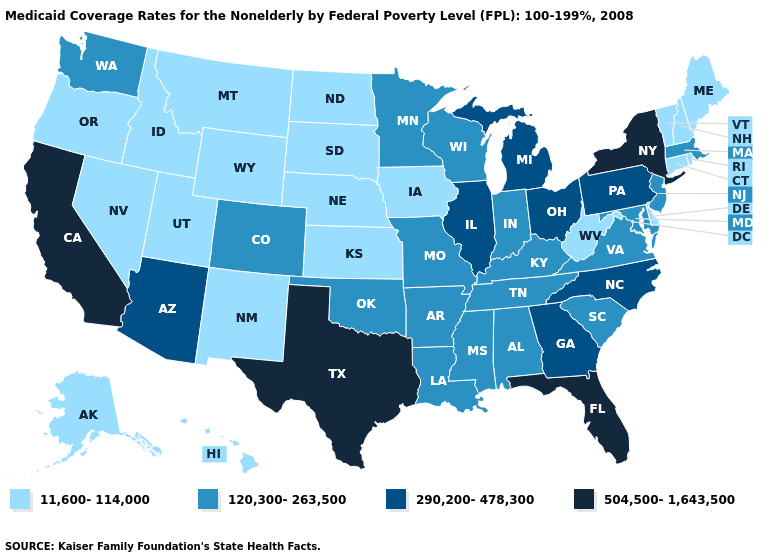Is the legend a continuous bar?
Short answer required. No. Name the states that have a value in the range 120,300-263,500?
Short answer required. Alabama, Arkansas, Colorado, Indiana, Kentucky, Louisiana, Maryland, Massachusetts, Minnesota, Mississippi, Missouri, New Jersey, Oklahoma, South Carolina, Tennessee, Virginia, Washington, Wisconsin. What is the value of Kansas?
Answer briefly. 11,600-114,000. Which states have the lowest value in the USA?
Concise answer only. Alaska, Connecticut, Delaware, Hawaii, Idaho, Iowa, Kansas, Maine, Montana, Nebraska, Nevada, New Hampshire, New Mexico, North Dakota, Oregon, Rhode Island, South Dakota, Utah, Vermont, West Virginia, Wyoming. Does Washington have a higher value than Idaho?
Quick response, please. Yes. What is the value of South Dakota?
Write a very short answer. 11,600-114,000. Which states have the lowest value in the USA?
Write a very short answer. Alaska, Connecticut, Delaware, Hawaii, Idaho, Iowa, Kansas, Maine, Montana, Nebraska, Nevada, New Hampshire, New Mexico, North Dakota, Oregon, Rhode Island, South Dakota, Utah, Vermont, West Virginia, Wyoming. Does the first symbol in the legend represent the smallest category?
Write a very short answer. Yes. Which states hav the highest value in the Northeast?
Write a very short answer. New York. What is the value of Wyoming?
Answer briefly. 11,600-114,000. Name the states that have a value in the range 504,500-1,643,500?
Write a very short answer. California, Florida, New York, Texas. Does the first symbol in the legend represent the smallest category?
Write a very short answer. Yes. Name the states that have a value in the range 504,500-1,643,500?
Answer briefly. California, Florida, New York, Texas. Does Idaho have the same value as Vermont?
Concise answer only. Yes. What is the lowest value in states that border Oregon?
Give a very brief answer. 11,600-114,000. 